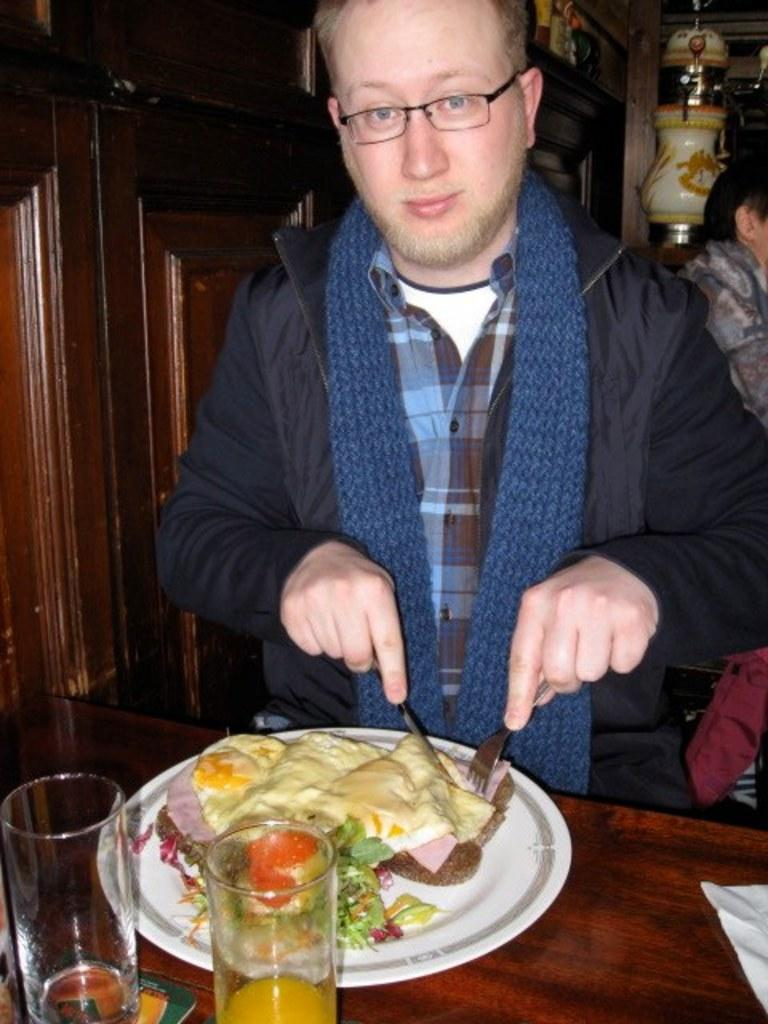What is the man in the image doing? The man is standing in the image and holding a knife and fork. What might the man be using the knife and fork for? The man might be using the knife and fork to eat the food items on the plate in the image. What is in the glass in the image? There is juice in the glass in the image. What type of circle is visible in the image? There is no circle present in the image. What day of the week is depicted in the image? The image does not depict a specific day of the week. 